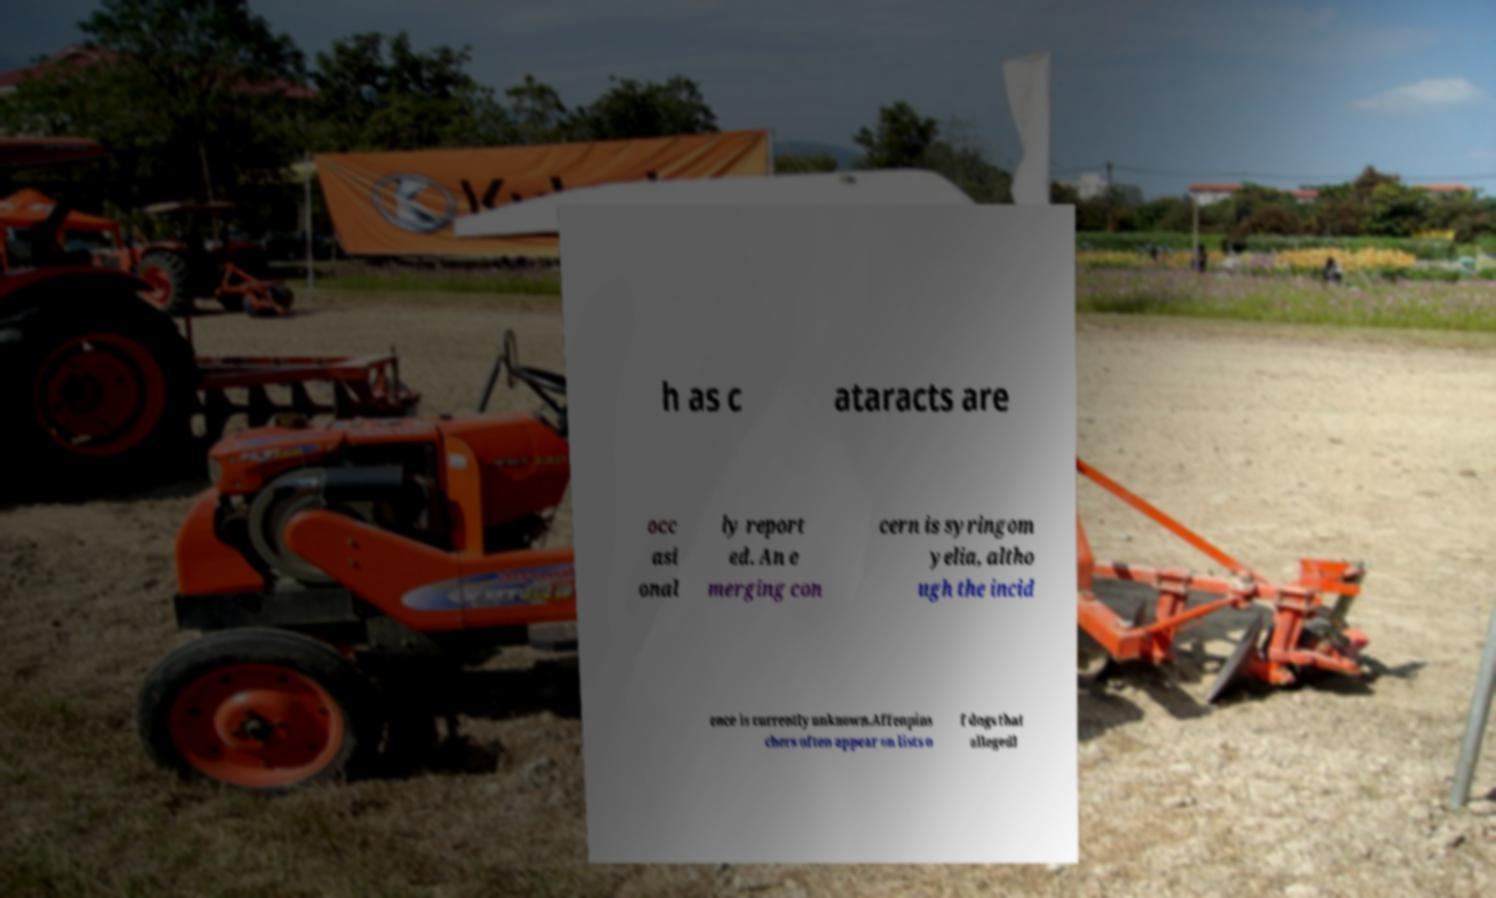Can you read and provide the text displayed in the image?This photo seems to have some interesting text. Can you extract and type it out for me? h as c ataracts are occ asi onal ly report ed. An e merging con cern is syringom yelia, altho ugh the incid ence is currently unknown.Affenpins chers often appear on lists o f dogs that allegedl 